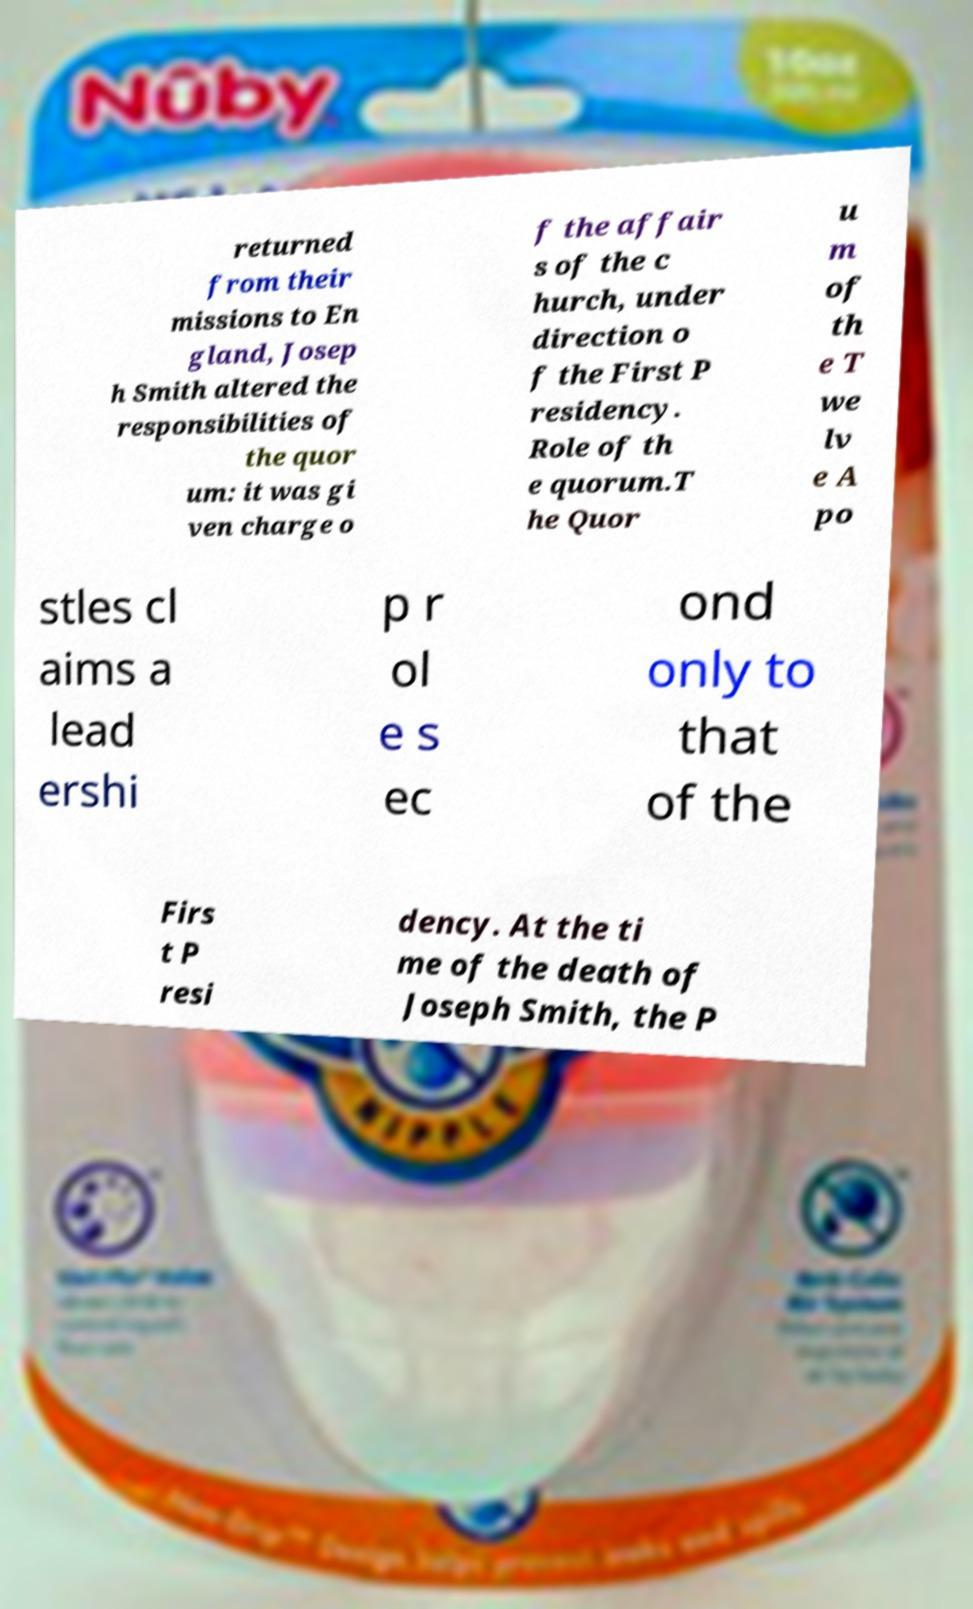Please identify and transcribe the text found in this image. returned from their missions to En gland, Josep h Smith altered the responsibilities of the quor um: it was gi ven charge o f the affair s of the c hurch, under direction o f the First P residency. Role of th e quorum.T he Quor u m of th e T we lv e A po stles cl aims a lead ershi p r ol e s ec ond only to that of the Firs t P resi dency. At the ti me of the death of Joseph Smith, the P 